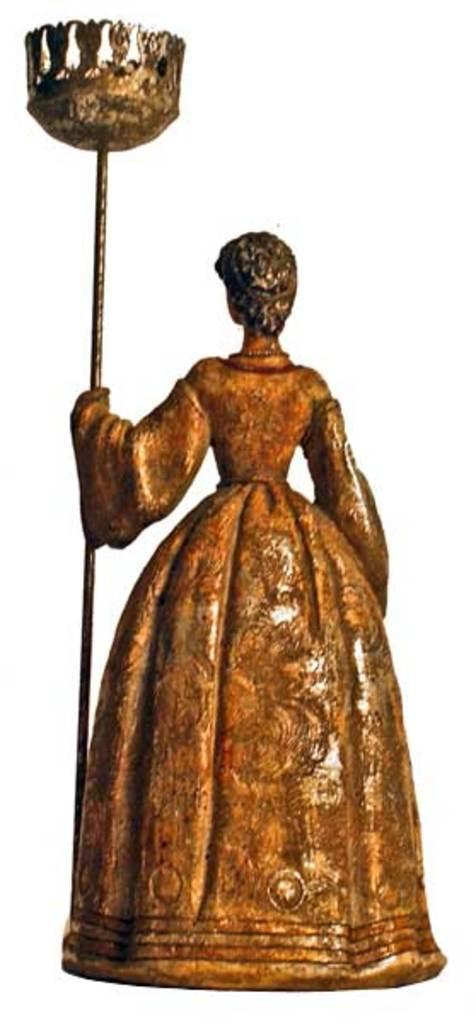What type of doll is in the image? There is a metal doll in the image. Can you describe the background of the image? The background of the image is blurred. What type of secretary is present in the image? There is no secretary present in the image; it only features a metal doll. What type of blade can be seen in the image? There is no blade present in the image. 